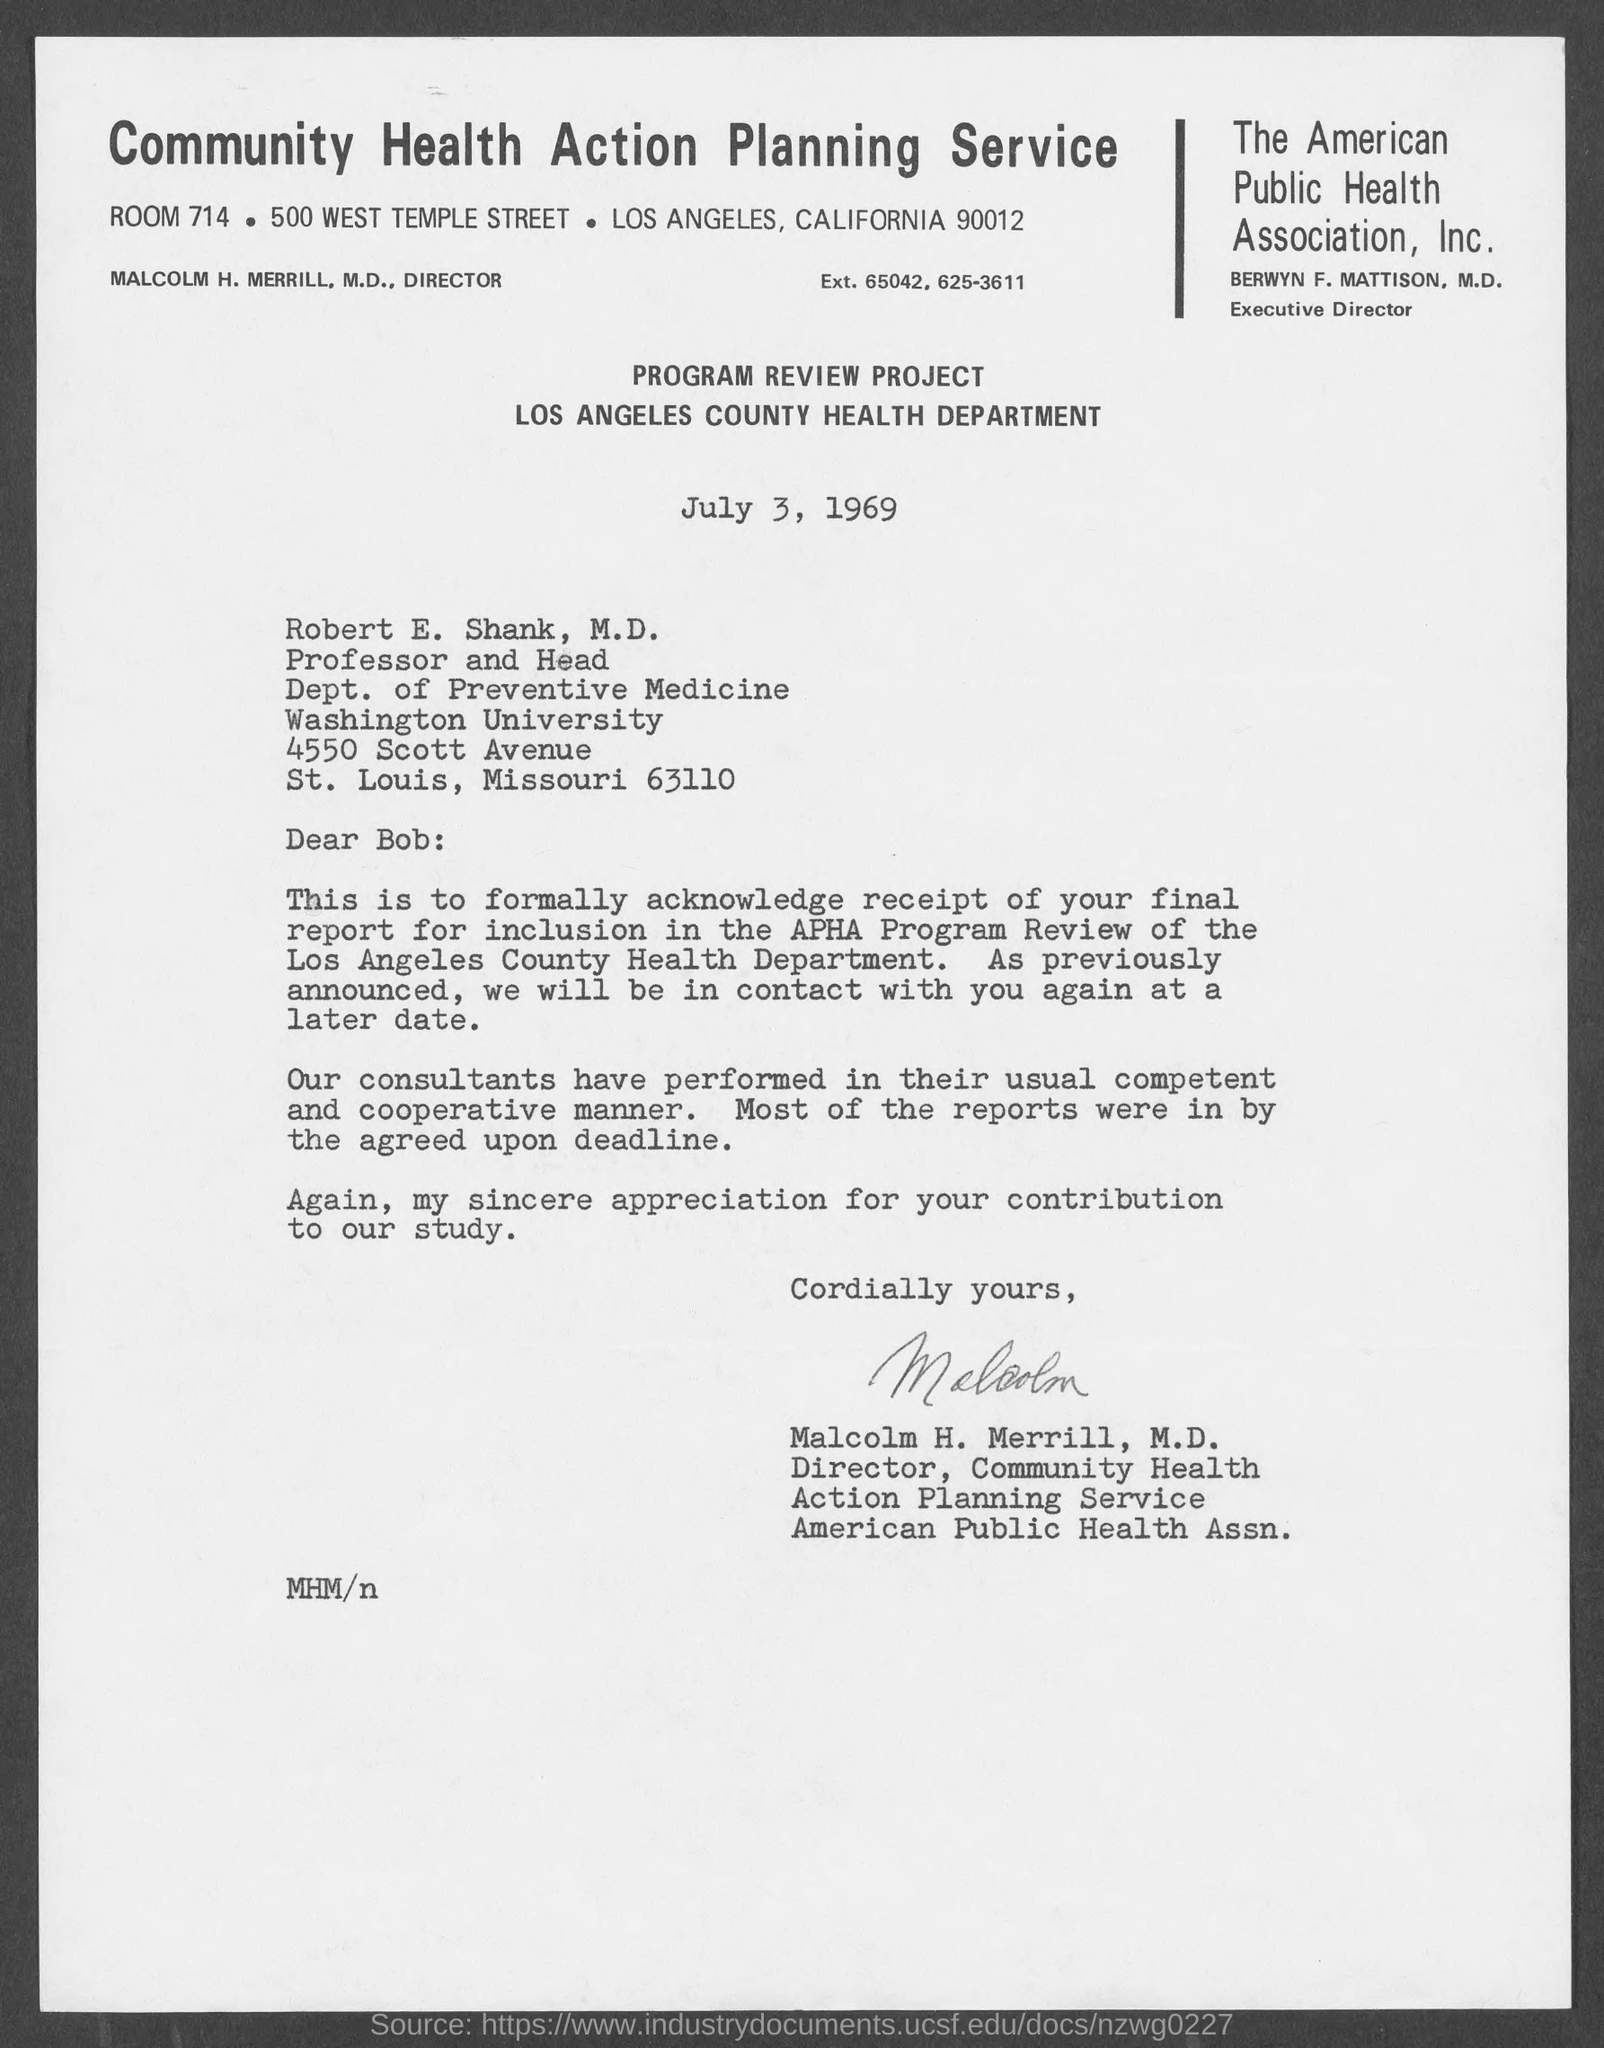Who is the professor and head of dept. of preventive medicine?
Keep it short and to the point. Robert E. Shank, M.D. What is the postal code of california?
Your response must be concise. 90012. Who is the director of community health action planning service?
Provide a short and direct response. Malcolm H. Merrill, M.D. Who is the executive director of the public health association, inc.
Offer a terse response. Berwyn F. Mattison, M.D. Who wrote this letter?
Make the answer very short. Malcolm H. Merrill, M.D. To whom this letter is written to?
Offer a terse response. Robert E. Shank, M.D. 